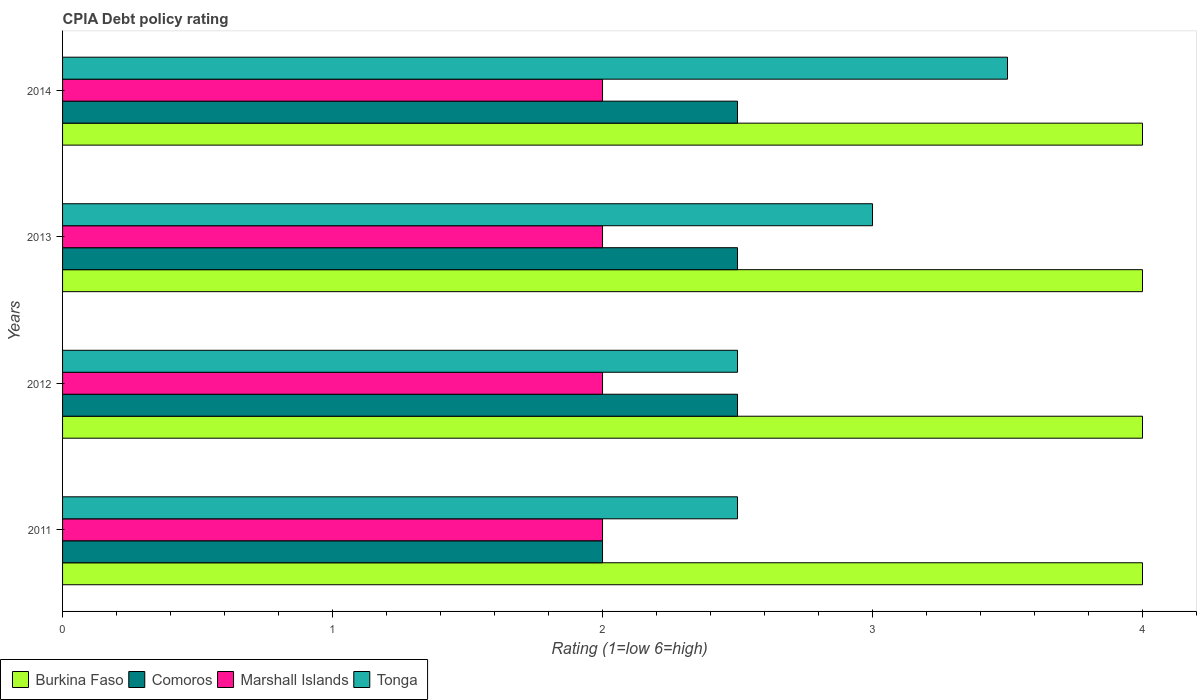How many groups of bars are there?
Ensure brevity in your answer.  4. Are the number of bars per tick equal to the number of legend labels?
Ensure brevity in your answer.  Yes. How many bars are there on the 4th tick from the top?
Ensure brevity in your answer.  4. How many bars are there on the 3rd tick from the bottom?
Your response must be concise. 4. In which year was the CPIA rating in Comoros minimum?
Provide a succinct answer. 2011. What is the average CPIA rating in Comoros per year?
Make the answer very short. 2.38. In how many years, is the CPIA rating in Comoros greater than 3.8 ?
Provide a succinct answer. 0. Is the CPIA rating in Burkina Faso in 2013 less than that in 2014?
Give a very brief answer. No. Is the difference between the CPIA rating in Comoros in 2013 and 2014 greater than the difference between the CPIA rating in Tonga in 2013 and 2014?
Provide a short and direct response. Yes. What is the difference between the highest and the lowest CPIA rating in Burkina Faso?
Offer a terse response. 0. What does the 3rd bar from the top in 2014 represents?
Offer a very short reply. Comoros. What does the 1st bar from the bottom in 2012 represents?
Offer a terse response. Burkina Faso. How many bars are there?
Your response must be concise. 16. Are all the bars in the graph horizontal?
Keep it short and to the point. Yes. What is the difference between two consecutive major ticks on the X-axis?
Give a very brief answer. 1. Does the graph contain grids?
Provide a succinct answer. No. What is the title of the graph?
Keep it short and to the point. CPIA Debt policy rating. What is the label or title of the X-axis?
Offer a terse response. Rating (1=low 6=high). What is the Rating (1=low 6=high) of Burkina Faso in 2011?
Offer a very short reply. 4. What is the Rating (1=low 6=high) of Tonga in 2011?
Give a very brief answer. 2.5. What is the Rating (1=low 6=high) in Tonga in 2012?
Offer a terse response. 2.5. What is the Rating (1=low 6=high) in Burkina Faso in 2013?
Offer a very short reply. 4. What is the Rating (1=low 6=high) of Burkina Faso in 2014?
Provide a succinct answer. 4. What is the Rating (1=low 6=high) of Marshall Islands in 2014?
Your answer should be compact. 2. Across all years, what is the maximum Rating (1=low 6=high) in Comoros?
Your answer should be compact. 2.5. Across all years, what is the maximum Rating (1=low 6=high) in Tonga?
Give a very brief answer. 3.5. Across all years, what is the minimum Rating (1=low 6=high) in Burkina Faso?
Make the answer very short. 4. Across all years, what is the minimum Rating (1=low 6=high) of Comoros?
Your answer should be very brief. 2. Across all years, what is the minimum Rating (1=low 6=high) in Marshall Islands?
Provide a succinct answer. 2. What is the total Rating (1=low 6=high) in Comoros in the graph?
Offer a very short reply. 9.5. What is the total Rating (1=low 6=high) of Tonga in the graph?
Provide a short and direct response. 11.5. What is the difference between the Rating (1=low 6=high) in Burkina Faso in 2011 and that in 2012?
Offer a terse response. 0. What is the difference between the Rating (1=low 6=high) in Comoros in 2011 and that in 2012?
Your answer should be compact. -0.5. What is the difference between the Rating (1=low 6=high) of Marshall Islands in 2011 and that in 2012?
Provide a succinct answer. 0. What is the difference between the Rating (1=low 6=high) of Comoros in 2011 and that in 2013?
Your answer should be very brief. -0.5. What is the difference between the Rating (1=low 6=high) of Marshall Islands in 2011 and that in 2013?
Ensure brevity in your answer.  0. What is the difference between the Rating (1=low 6=high) of Comoros in 2011 and that in 2014?
Make the answer very short. -0.5. What is the difference between the Rating (1=low 6=high) in Marshall Islands in 2011 and that in 2014?
Give a very brief answer. 0. What is the difference between the Rating (1=low 6=high) in Comoros in 2012 and that in 2013?
Ensure brevity in your answer.  0. What is the difference between the Rating (1=low 6=high) of Tonga in 2012 and that in 2014?
Make the answer very short. -1. What is the difference between the Rating (1=low 6=high) of Marshall Islands in 2013 and that in 2014?
Your answer should be compact. 0. What is the difference between the Rating (1=low 6=high) of Tonga in 2013 and that in 2014?
Keep it short and to the point. -0.5. What is the difference between the Rating (1=low 6=high) of Burkina Faso in 2011 and the Rating (1=low 6=high) of Comoros in 2012?
Offer a very short reply. 1.5. What is the difference between the Rating (1=low 6=high) of Burkina Faso in 2011 and the Rating (1=low 6=high) of Marshall Islands in 2012?
Keep it short and to the point. 2. What is the difference between the Rating (1=low 6=high) of Burkina Faso in 2011 and the Rating (1=low 6=high) of Tonga in 2012?
Your answer should be very brief. 1.5. What is the difference between the Rating (1=low 6=high) in Comoros in 2011 and the Rating (1=low 6=high) in Tonga in 2012?
Ensure brevity in your answer.  -0.5. What is the difference between the Rating (1=low 6=high) of Marshall Islands in 2011 and the Rating (1=low 6=high) of Tonga in 2012?
Provide a succinct answer. -0.5. What is the difference between the Rating (1=low 6=high) of Burkina Faso in 2011 and the Rating (1=low 6=high) of Comoros in 2013?
Offer a very short reply. 1.5. What is the difference between the Rating (1=low 6=high) in Burkina Faso in 2011 and the Rating (1=low 6=high) in Marshall Islands in 2013?
Offer a terse response. 2. What is the difference between the Rating (1=low 6=high) of Comoros in 2011 and the Rating (1=low 6=high) of Marshall Islands in 2013?
Ensure brevity in your answer.  0. What is the difference between the Rating (1=low 6=high) of Burkina Faso in 2011 and the Rating (1=low 6=high) of Marshall Islands in 2014?
Offer a terse response. 2. What is the difference between the Rating (1=low 6=high) in Comoros in 2011 and the Rating (1=low 6=high) in Marshall Islands in 2014?
Offer a very short reply. 0. What is the difference between the Rating (1=low 6=high) of Comoros in 2011 and the Rating (1=low 6=high) of Tonga in 2014?
Offer a very short reply. -1.5. What is the difference between the Rating (1=low 6=high) in Burkina Faso in 2012 and the Rating (1=low 6=high) in Comoros in 2013?
Your answer should be compact. 1.5. What is the difference between the Rating (1=low 6=high) in Marshall Islands in 2012 and the Rating (1=low 6=high) in Tonga in 2013?
Ensure brevity in your answer.  -1. What is the difference between the Rating (1=low 6=high) in Comoros in 2012 and the Rating (1=low 6=high) in Marshall Islands in 2014?
Your response must be concise. 0.5. What is the difference between the Rating (1=low 6=high) in Comoros in 2012 and the Rating (1=low 6=high) in Tonga in 2014?
Your answer should be very brief. -1. What is the difference between the Rating (1=low 6=high) of Burkina Faso in 2013 and the Rating (1=low 6=high) of Tonga in 2014?
Provide a succinct answer. 0.5. What is the average Rating (1=low 6=high) of Comoros per year?
Your answer should be compact. 2.38. What is the average Rating (1=low 6=high) in Marshall Islands per year?
Give a very brief answer. 2. What is the average Rating (1=low 6=high) in Tonga per year?
Your response must be concise. 2.88. In the year 2011, what is the difference between the Rating (1=low 6=high) of Burkina Faso and Rating (1=low 6=high) of Marshall Islands?
Make the answer very short. 2. In the year 2011, what is the difference between the Rating (1=low 6=high) of Comoros and Rating (1=low 6=high) of Marshall Islands?
Make the answer very short. 0. In the year 2011, what is the difference between the Rating (1=low 6=high) of Comoros and Rating (1=low 6=high) of Tonga?
Keep it short and to the point. -0.5. In the year 2011, what is the difference between the Rating (1=low 6=high) of Marshall Islands and Rating (1=low 6=high) of Tonga?
Provide a short and direct response. -0.5. In the year 2012, what is the difference between the Rating (1=low 6=high) of Burkina Faso and Rating (1=low 6=high) of Comoros?
Offer a terse response. 1.5. In the year 2012, what is the difference between the Rating (1=low 6=high) of Comoros and Rating (1=low 6=high) of Marshall Islands?
Ensure brevity in your answer.  0.5. In the year 2012, what is the difference between the Rating (1=low 6=high) in Marshall Islands and Rating (1=low 6=high) in Tonga?
Provide a short and direct response. -0.5. In the year 2013, what is the difference between the Rating (1=low 6=high) in Burkina Faso and Rating (1=low 6=high) in Comoros?
Give a very brief answer. 1.5. In the year 2013, what is the difference between the Rating (1=low 6=high) in Burkina Faso and Rating (1=low 6=high) in Tonga?
Your answer should be very brief. 1. In the year 2013, what is the difference between the Rating (1=low 6=high) of Comoros and Rating (1=low 6=high) of Marshall Islands?
Keep it short and to the point. 0.5. In the year 2013, what is the difference between the Rating (1=low 6=high) in Comoros and Rating (1=low 6=high) in Tonga?
Your answer should be compact. -0.5. In the year 2014, what is the difference between the Rating (1=low 6=high) of Marshall Islands and Rating (1=low 6=high) of Tonga?
Provide a succinct answer. -1.5. What is the ratio of the Rating (1=low 6=high) in Comoros in 2011 to that in 2012?
Your answer should be compact. 0.8. What is the ratio of the Rating (1=low 6=high) of Marshall Islands in 2011 to that in 2012?
Give a very brief answer. 1. What is the ratio of the Rating (1=low 6=high) in Burkina Faso in 2011 to that in 2013?
Offer a very short reply. 1. What is the ratio of the Rating (1=low 6=high) of Comoros in 2011 to that in 2013?
Keep it short and to the point. 0.8. What is the ratio of the Rating (1=low 6=high) in Marshall Islands in 2011 to that in 2013?
Provide a short and direct response. 1. What is the ratio of the Rating (1=low 6=high) of Marshall Islands in 2011 to that in 2014?
Offer a very short reply. 1. What is the ratio of the Rating (1=low 6=high) in Comoros in 2012 to that in 2013?
Ensure brevity in your answer.  1. What is the ratio of the Rating (1=low 6=high) of Marshall Islands in 2012 to that in 2013?
Ensure brevity in your answer.  1. What is the ratio of the Rating (1=low 6=high) of Burkina Faso in 2012 to that in 2014?
Provide a short and direct response. 1. What is the ratio of the Rating (1=low 6=high) of Comoros in 2012 to that in 2014?
Offer a terse response. 1. What is the ratio of the Rating (1=low 6=high) of Marshall Islands in 2012 to that in 2014?
Offer a very short reply. 1. What is the ratio of the Rating (1=low 6=high) in Tonga in 2013 to that in 2014?
Offer a terse response. 0.86. What is the difference between the highest and the lowest Rating (1=low 6=high) of Comoros?
Your answer should be very brief. 0.5. What is the difference between the highest and the lowest Rating (1=low 6=high) of Marshall Islands?
Your response must be concise. 0. What is the difference between the highest and the lowest Rating (1=low 6=high) of Tonga?
Give a very brief answer. 1. 